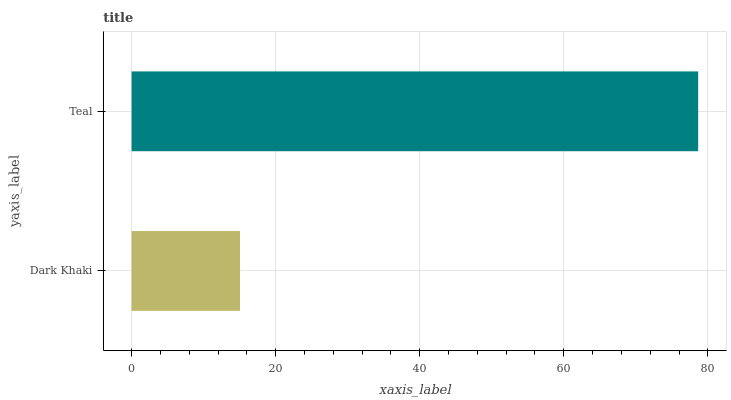Is Dark Khaki the minimum?
Answer yes or no. Yes. Is Teal the maximum?
Answer yes or no. Yes. Is Teal the minimum?
Answer yes or no. No. Is Teal greater than Dark Khaki?
Answer yes or no. Yes. Is Dark Khaki less than Teal?
Answer yes or no. Yes. Is Dark Khaki greater than Teal?
Answer yes or no. No. Is Teal less than Dark Khaki?
Answer yes or no. No. Is Teal the high median?
Answer yes or no. Yes. Is Dark Khaki the low median?
Answer yes or no. Yes. Is Dark Khaki the high median?
Answer yes or no. No. Is Teal the low median?
Answer yes or no. No. 